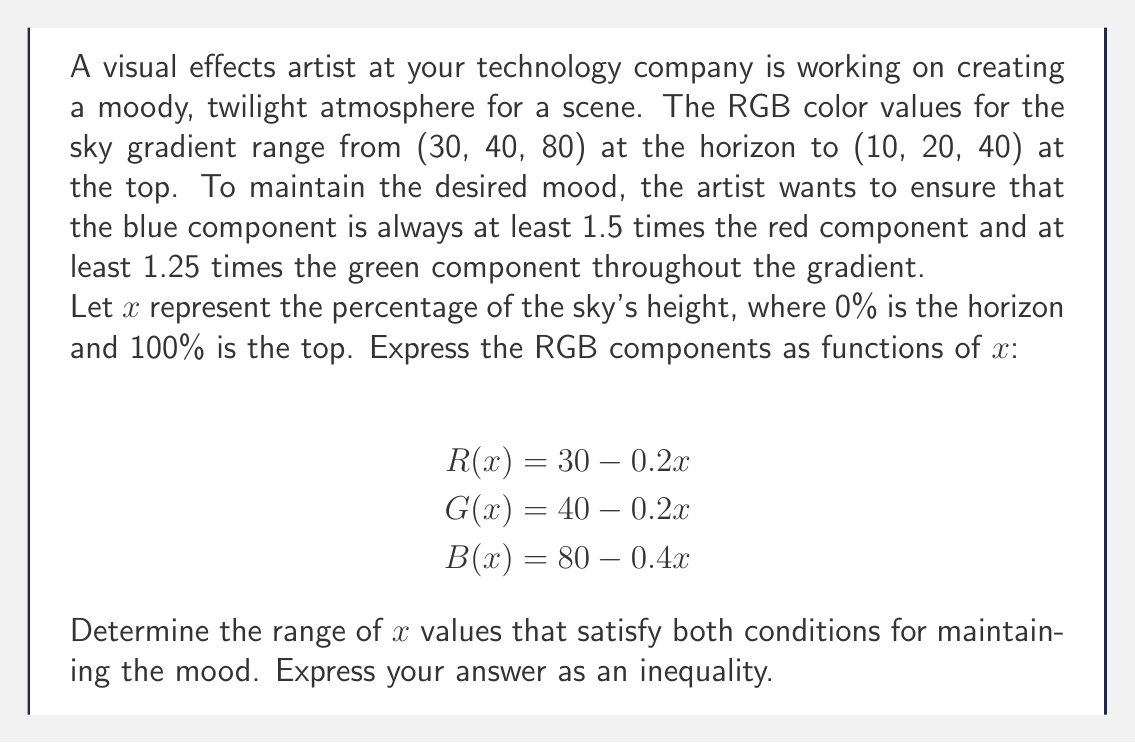Can you solve this math problem? To solve this problem, we need to set up and solve two inequalities based on the given conditions:

1. Blue component is at least 1.5 times the red component:
   $B(x) \ge 1.5R(x)$

2. Blue component is at least 1.25 times the green component:
   $B(x) \ge 1.25G(x)$

Let's solve each inequality:

1. $B(x) \ge 1.5R(x)$
   $80 - 0.4x \ge 1.5(30 - 0.2x)$
   $80 - 0.4x \ge 45 - 0.3x$
   $80 - 45 \ge 0.4x - 0.3x$
   $35 \ge 0.1x$
   $350 \ge x$

2. $B(x) \ge 1.25G(x)$
   $80 - 0.4x \ge 1.25(40 - 0.2x)$
   $80 - 0.4x \ge 50 - 0.25x$
   $80 - 50 \ge 0.4x - 0.25x$
   $30 \ge 0.15x$
   $200 \ge x$

To satisfy both conditions, we need to take the more restrictive inequality, which is $x \le 200$.

However, we also need to consider the domain of $x$, which represents the percentage of the sky's height. Therefore, $x$ must be between 0 and 100.

Combining these constraints, we get:

$0 \le x \le 100$

This means that the conditions are satisfied for the entire range of the sky gradient.
Answer: $0 \le x \le 100$ 